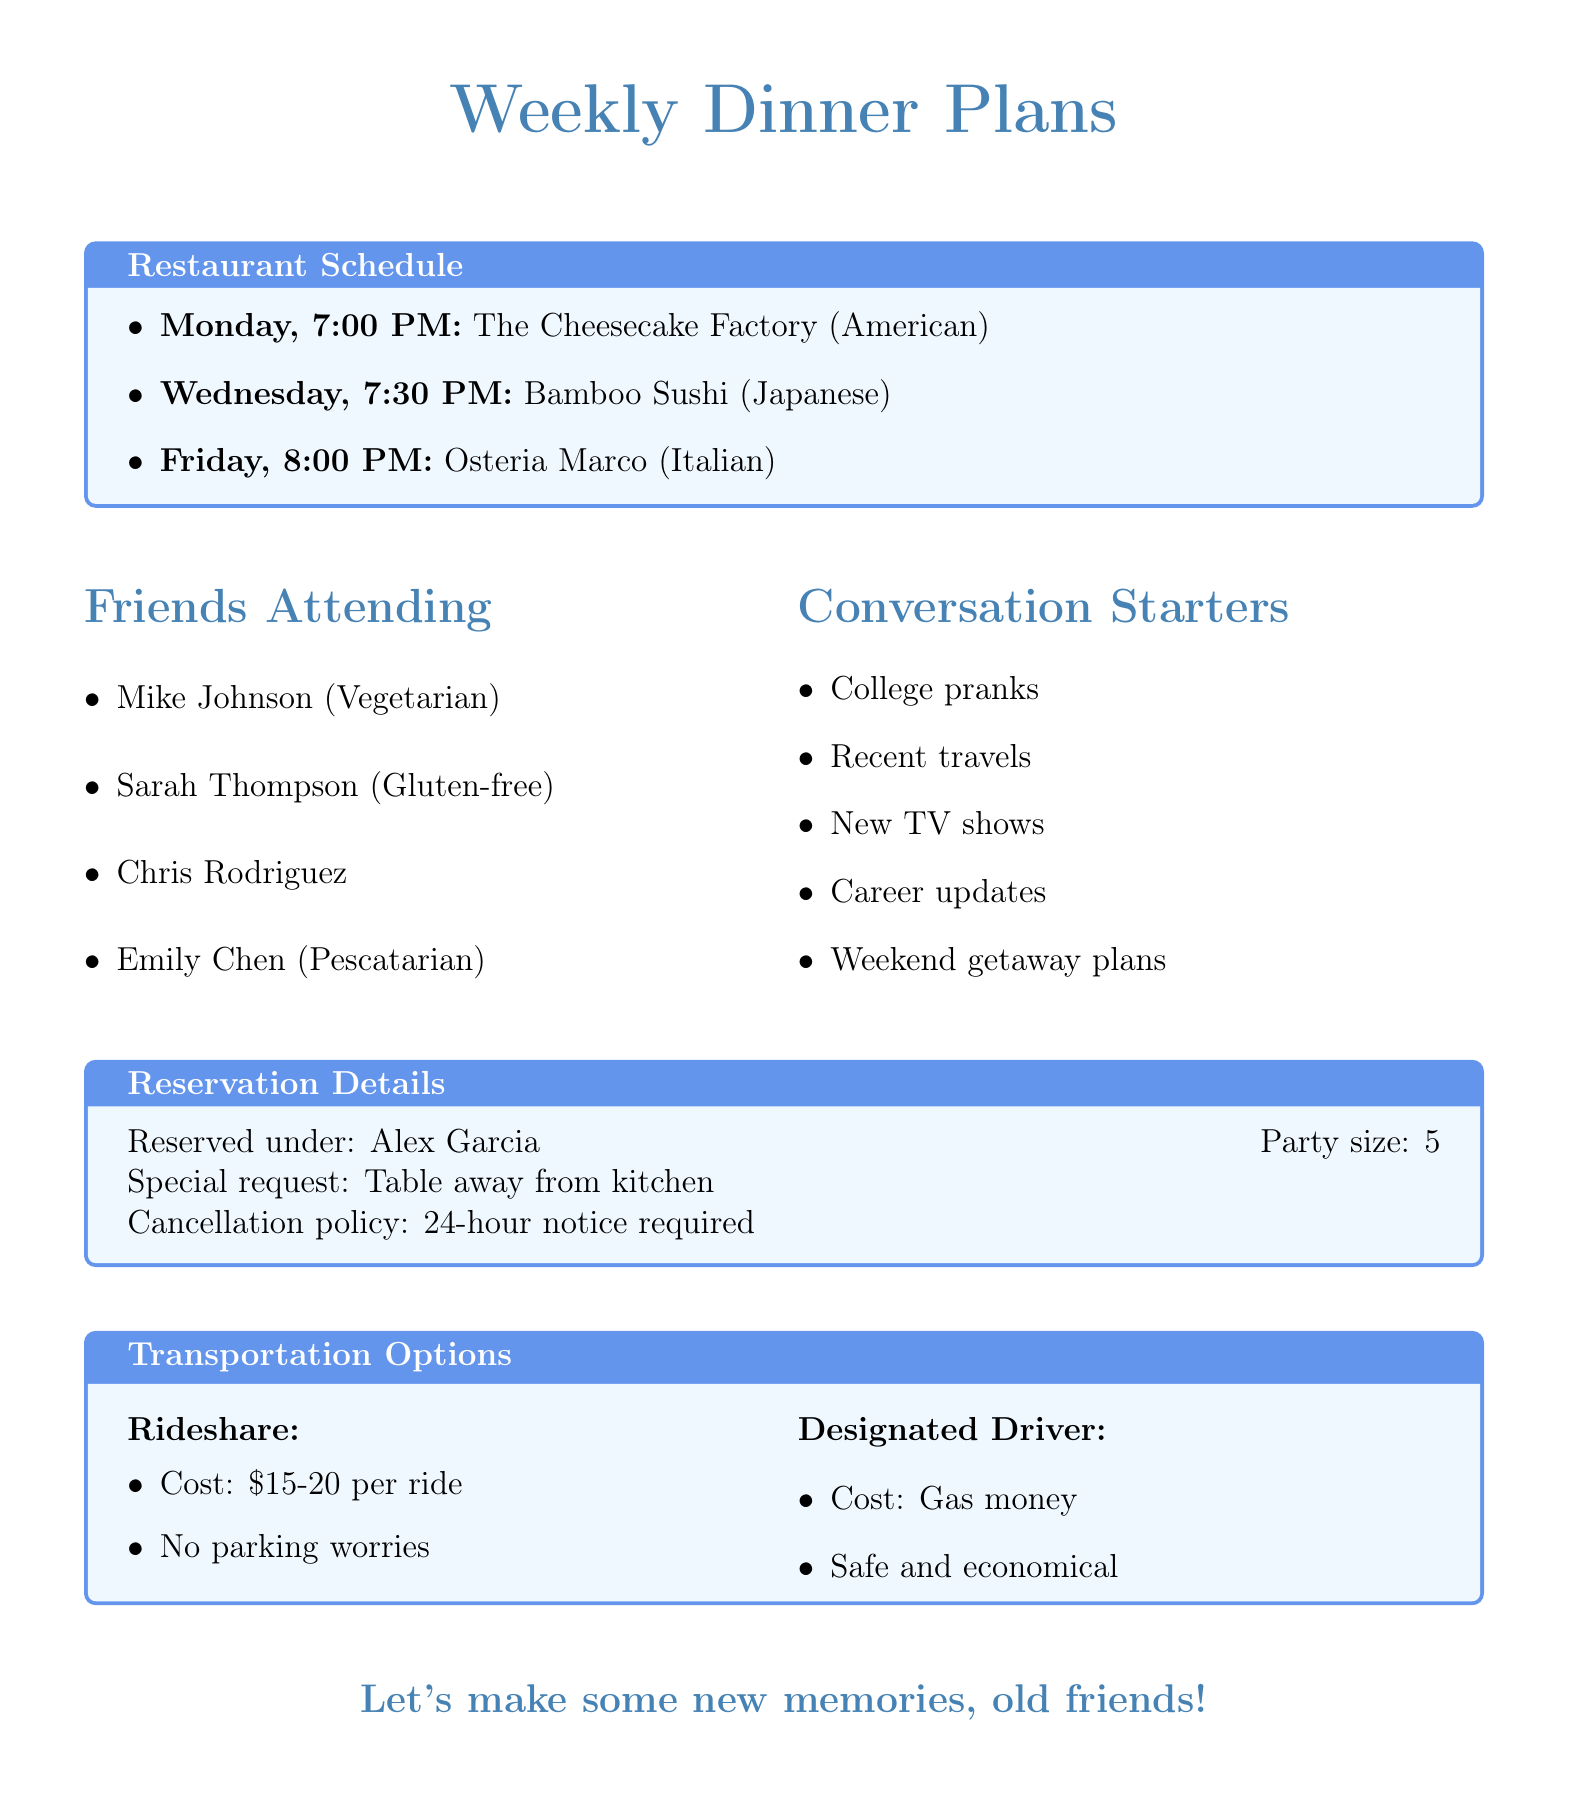What restaurant is reserved for Monday? The document lists The Cheesecake Factory as the restaurant for Monday.
Answer: The Cheesecake Factory What time is the reservation at Bamboo Sushi? The document specifies that the reservation at Bamboo Sushi is at 7:30 PM.
Answer: 7:30 PM How many friends are attending the dinners? The document indicates there are a total of five friends attending.
Answer: 5 Which friend has a gluten-free dietary restriction? From the document, Sarah Thompson is noted to have a gluten-free dietary restriction.
Answer: Sarah Thompson What is the cancellation policy mentioned? The document states that a 24-hour notice is required to avoid a fee for cancellation.
Answer: 24-hour notice Which restaurant has a special note about happy hour? The document mentions The Cheesecake Factory has a special note about happy hour until 6:30 PM.
Answer: The Cheesecake Factory What type of cuisine is served at Osteria Marco? The document identifies Osteria Marco as serving Italian cuisine.
Answer: Italian What transportation method has an estimated cost of $15-20? Rideshare is the transportation method mentioned in the document with that estimated cost.
Answer: Rideshare 